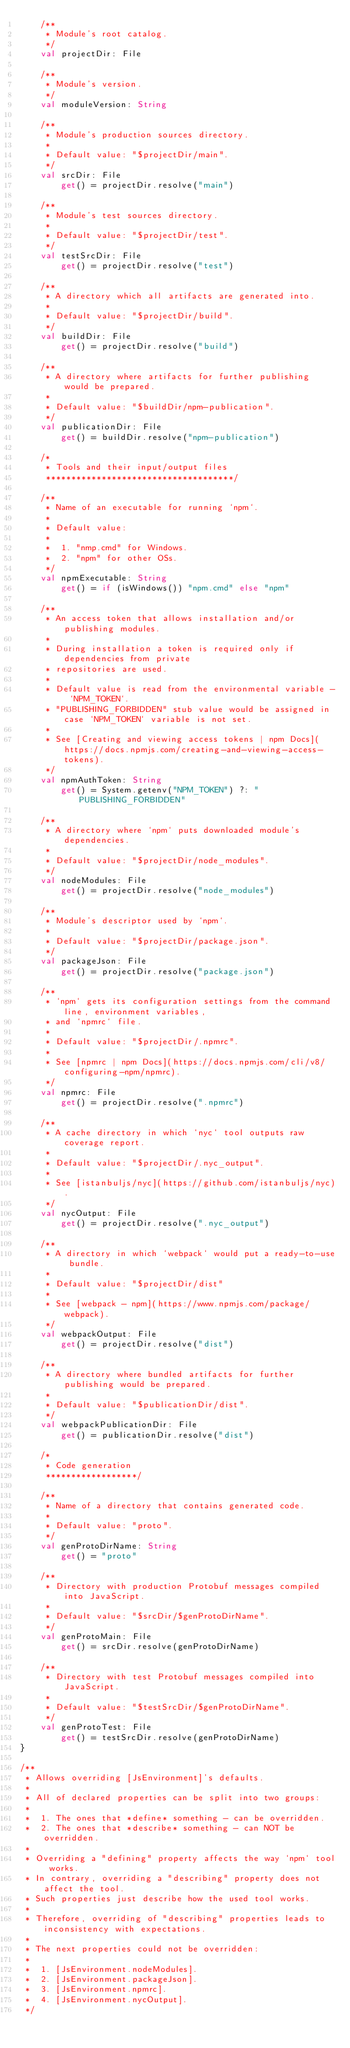Convert code to text. <code><loc_0><loc_0><loc_500><loc_500><_Kotlin_>    /**
     * Module's root catalog.
     */
    val projectDir: File

    /**
     * Module's version.
     */
    val moduleVersion: String

    /**
     * Module's production sources directory.
     *
     * Default value: "$projectDir/main".
     */
    val srcDir: File
        get() = projectDir.resolve("main")

    /**
     * Module's test sources directory.
     *
     * Default value: "$projectDir/test".
     */
    val testSrcDir: File
        get() = projectDir.resolve("test")

    /**
     * A directory which all artifacts are generated into.
     *
     * Default value: "$projectDir/build".
     */
    val buildDir: File
        get() = projectDir.resolve("build")

    /**
     * A directory where artifacts for further publishing would be prepared.
     *
     * Default value: "$buildDir/npm-publication".
     */
    val publicationDir: File
        get() = buildDir.resolve("npm-publication")

    /*
     * Tools and their input/output files
     *************************************/

    /**
     * Name of an executable for running `npm`.
     *
     * Default value:
     *
     *  1. "nmp.cmd" for Windows.
     *  2. "npm" for other OSs.
     */
    val npmExecutable: String
        get() = if (isWindows()) "npm.cmd" else "npm"

    /**
     * An access token that allows installation and/or publishing modules.
     *
     * During installation a token is required only if dependencies from private
     * repositories are used.
     *
     * Default value is read from the environmental variable - `NPM_TOKEN`.
     * "PUBLISHING_FORBIDDEN" stub value would be assigned in case `NPM_TOKEN` variable is not set.
     *
     * See [Creating and viewing access tokens | npm Docs](https://docs.npmjs.com/creating-and-viewing-access-tokens).
     */
    val npmAuthToken: String
        get() = System.getenv("NPM_TOKEN") ?: "PUBLISHING_FORBIDDEN"

    /**
     * A directory where `npm` puts downloaded module's dependencies.
     *
     * Default value: "$projectDir/node_modules".
     */
    val nodeModules: File
        get() = projectDir.resolve("node_modules")

    /**
     * Module's descriptor used by `npm`.
     *
     * Default value: "$projectDir/package.json".
     */
    val packageJson: File
        get() = projectDir.resolve("package.json")

    /**
     * `npm` gets its configuration settings from the command line, environment variables,
     * and `npmrc` file.
     *
     * Default value: "$projectDir/.npmrc".
     *
     * See [npmrc | npm Docs](https://docs.npmjs.com/cli/v8/configuring-npm/npmrc).
     */
    val npmrc: File
        get() = projectDir.resolve(".npmrc")

    /**
     * A cache directory in which `nyc` tool outputs raw coverage report.
     *
     * Default value: "$projectDir/.nyc_output".
     *
     * See [istanbuljs/nyc](https://github.com/istanbuljs/nyc).
     */
    val nycOutput: File
        get() = projectDir.resolve(".nyc_output")

    /**
     * A directory in which `webpack` would put a ready-to-use bundle.
     *
     * Default value: "$projectDir/dist"
     *
     * See [webpack - npm](https://www.npmjs.com/package/webpack).
     */
    val webpackOutput: File
        get() = projectDir.resolve("dist")

    /**
     * A directory where bundled artifacts for further publishing would be prepared.
     *
     * Default value: "$publicationDir/dist".
     */
    val webpackPublicationDir: File
        get() = publicationDir.resolve("dist")

    /*
     * Code generation
     ******************/

    /**
     * Name of a directory that contains generated code.
     *
     * Default value: "proto".
     */
    val genProtoDirName: String
        get() = "proto"

    /**
     * Directory with production Protobuf messages compiled into JavaScript.
     *
     * Default value: "$srcDir/$genProtoDirName".
     */
    val genProtoMain: File
        get() = srcDir.resolve(genProtoDirName)

    /**
     * Directory with test Protobuf messages compiled into JavaScript.
     *
     * Default value: "$testSrcDir/$genProtoDirName".
     */
    val genProtoTest: File
        get() = testSrcDir.resolve(genProtoDirName)
}

/**
 * Allows overriding [JsEnvironment]'s defaults.
 *
 * All of declared properties can be split into two groups:
 *
 *  1. The ones that *define* something - can be overridden.
 *  2. The ones that *describe* something - can NOT be overridden.
 *
 * Overriding a "defining" property affects the way `npm` tool works.
 * In contrary, overriding a "describing" property does not affect the tool.
 * Such properties just describe how the used tool works.
 *
 * Therefore, overriding of "describing" properties leads to inconsistency with expectations.
 *
 * The next properties could not be overridden:
 *
 *  1. [JsEnvironment.nodeModules].
 *  2. [JsEnvironment.packageJson].
 *  3. [JsEnvironment.npmrc].
 *  4. [JsEnvironment.nycOutput].
 */</code> 